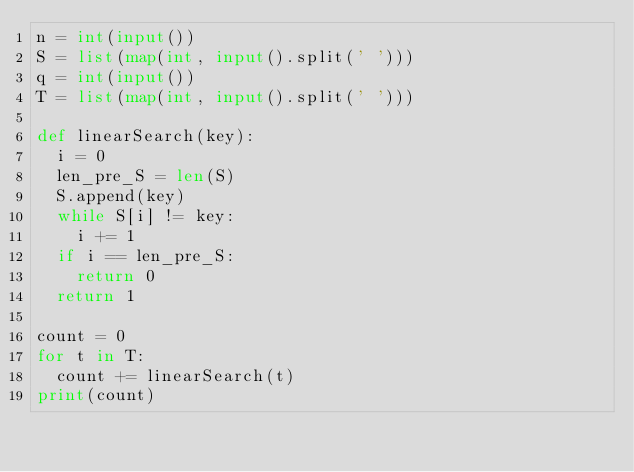Convert code to text. <code><loc_0><loc_0><loc_500><loc_500><_Python_>n = int(input())
S = list(map(int, input().split(' ')))
q = int(input())
T = list(map(int, input().split(' ')))

def linearSearch(key):
  i = 0
  len_pre_S = len(S)
  S.append(key)
  while S[i] != key:
    i += 1
  if i == len_pre_S:
    return 0
  return 1

count = 0
for t in T:
  count += linearSearch(t)
print(count)
</code> 